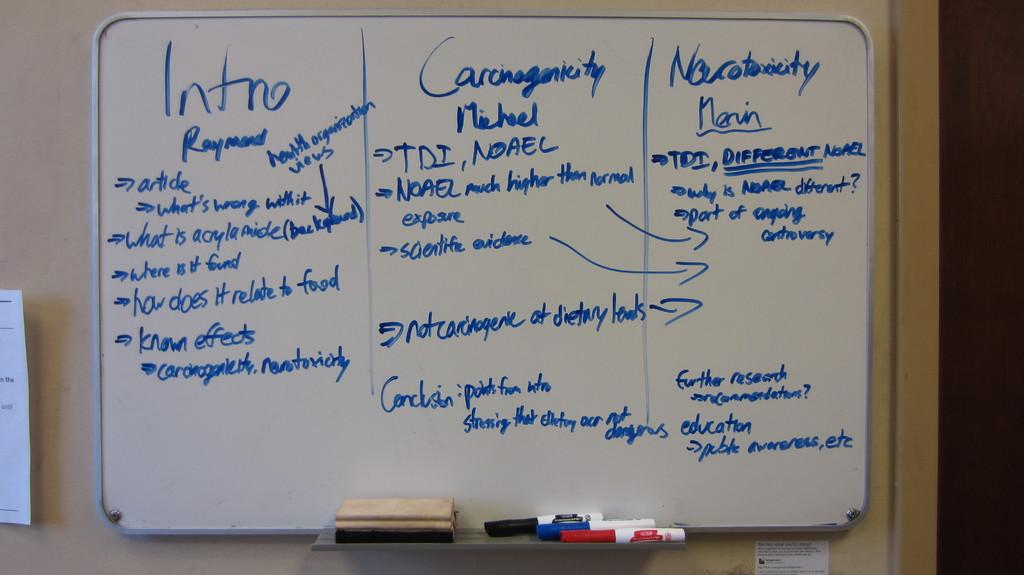<image>
Write a terse but informative summary of the picture. A dry erase board on a wall divided into 3 sections labeled Intro, and two others. 